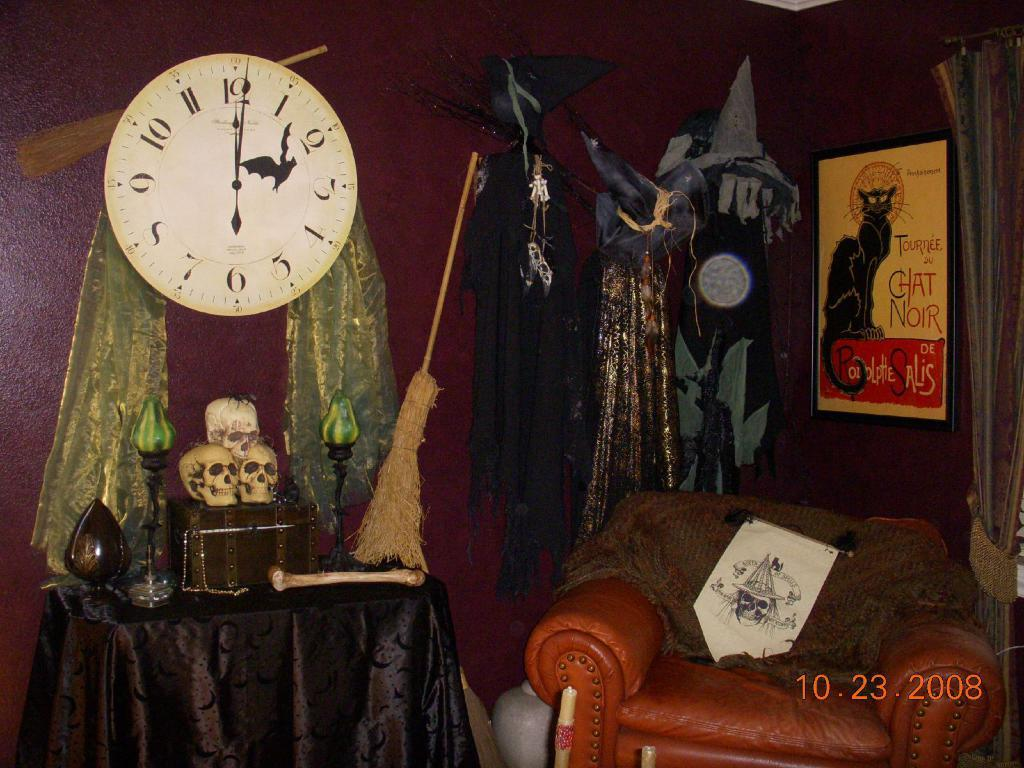<image>
Relay a brief, clear account of the picture shown. A sign about a cat and talking about a chat is on the wall above a chair. 